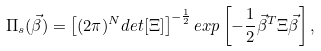Convert formula to latex. <formula><loc_0><loc_0><loc_500><loc_500>\Pi _ { s } ( \vec { \beta } ) = \left [ ( 2 \pi ) ^ { N } d e t [ \Xi ] \right ] ^ { - \frac { 1 } { 2 } } e x p \left [ - \frac { 1 } { 2 } \vec { \beta } ^ { T } \Xi \vec { \beta } \right ] ,</formula> 